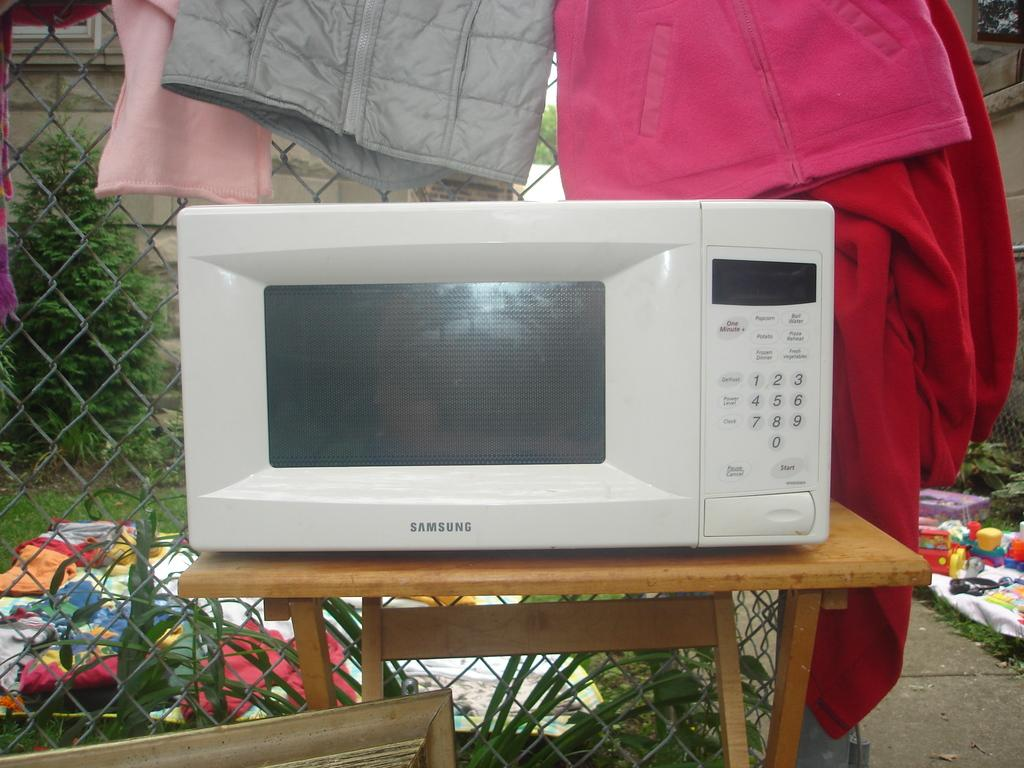<image>
Render a clear and concise summary of the photo. A white microwave on a table, and the microwave is by Samsung. 